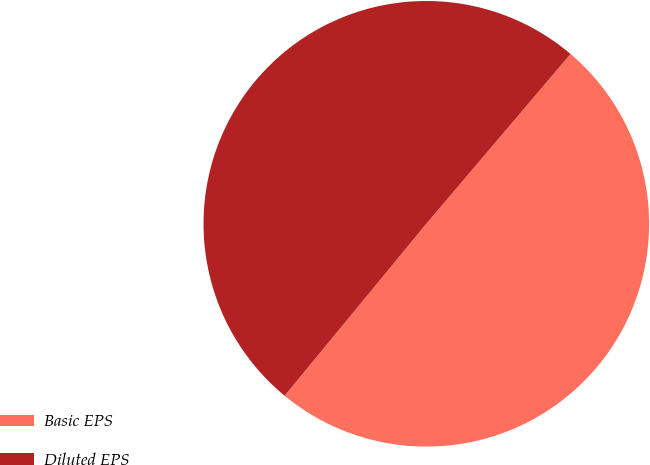Convert chart to OTSL. <chart><loc_0><loc_0><loc_500><loc_500><pie_chart><fcel>Basic EPS<fcel>Diluted EPS<nl><fcel>49.76%<fcel>50.24%<nl></chart> 